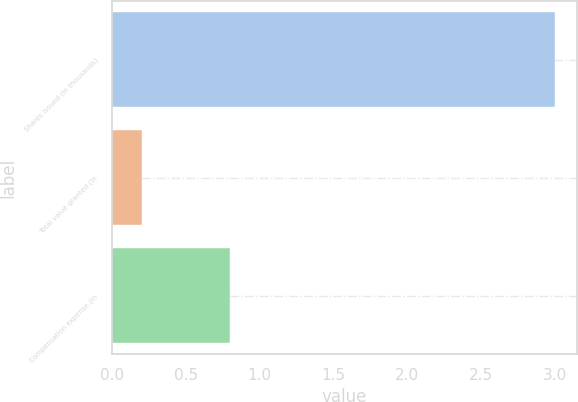<chart> <loc_0><loc_0><loc_500><loc_500><bar_chart><fcel>Shares issued (in thousands)<fcel>Total value granted (in<fcel>Compensation expense (in<nl><fcel>3<fcel>0.2<fcel>0.8<nl></chart> 